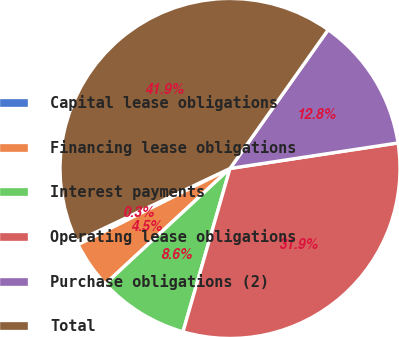<chart> <loc_0><loc_0><loc_500><loc_500><pie_chart><fcel>Capital lease obligations<fcel>Financing lease obligations<fcel>Interest payments<fcel>Operating lease obligations<fcel>Purchase obligations (2)<fcel>Total<nl><fcel>0.34%<fcel>4.49%<fcel>8.65%<fcel>31.86%<fcel>12.8%<fcel>41.86%<nl></chart> 